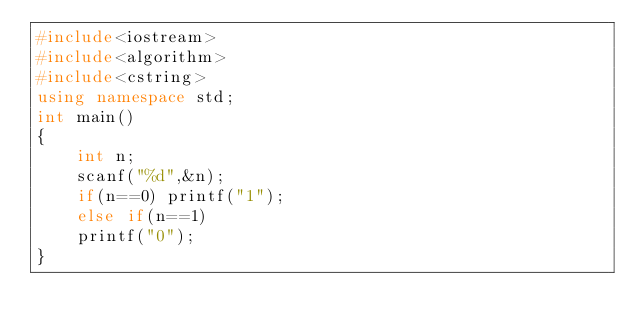Convert code to text. <code><loc_0><loc_0><loc_500><loc_500><_C++_>#include<iostream>
#include<algorithm>
#include<cstring>
using namespace std;
int main()
{
	int n;
	scanf("%d",&n);
	if(n==0) printf("1");	
	else if(n==1)
	printf("0");
} </code> 